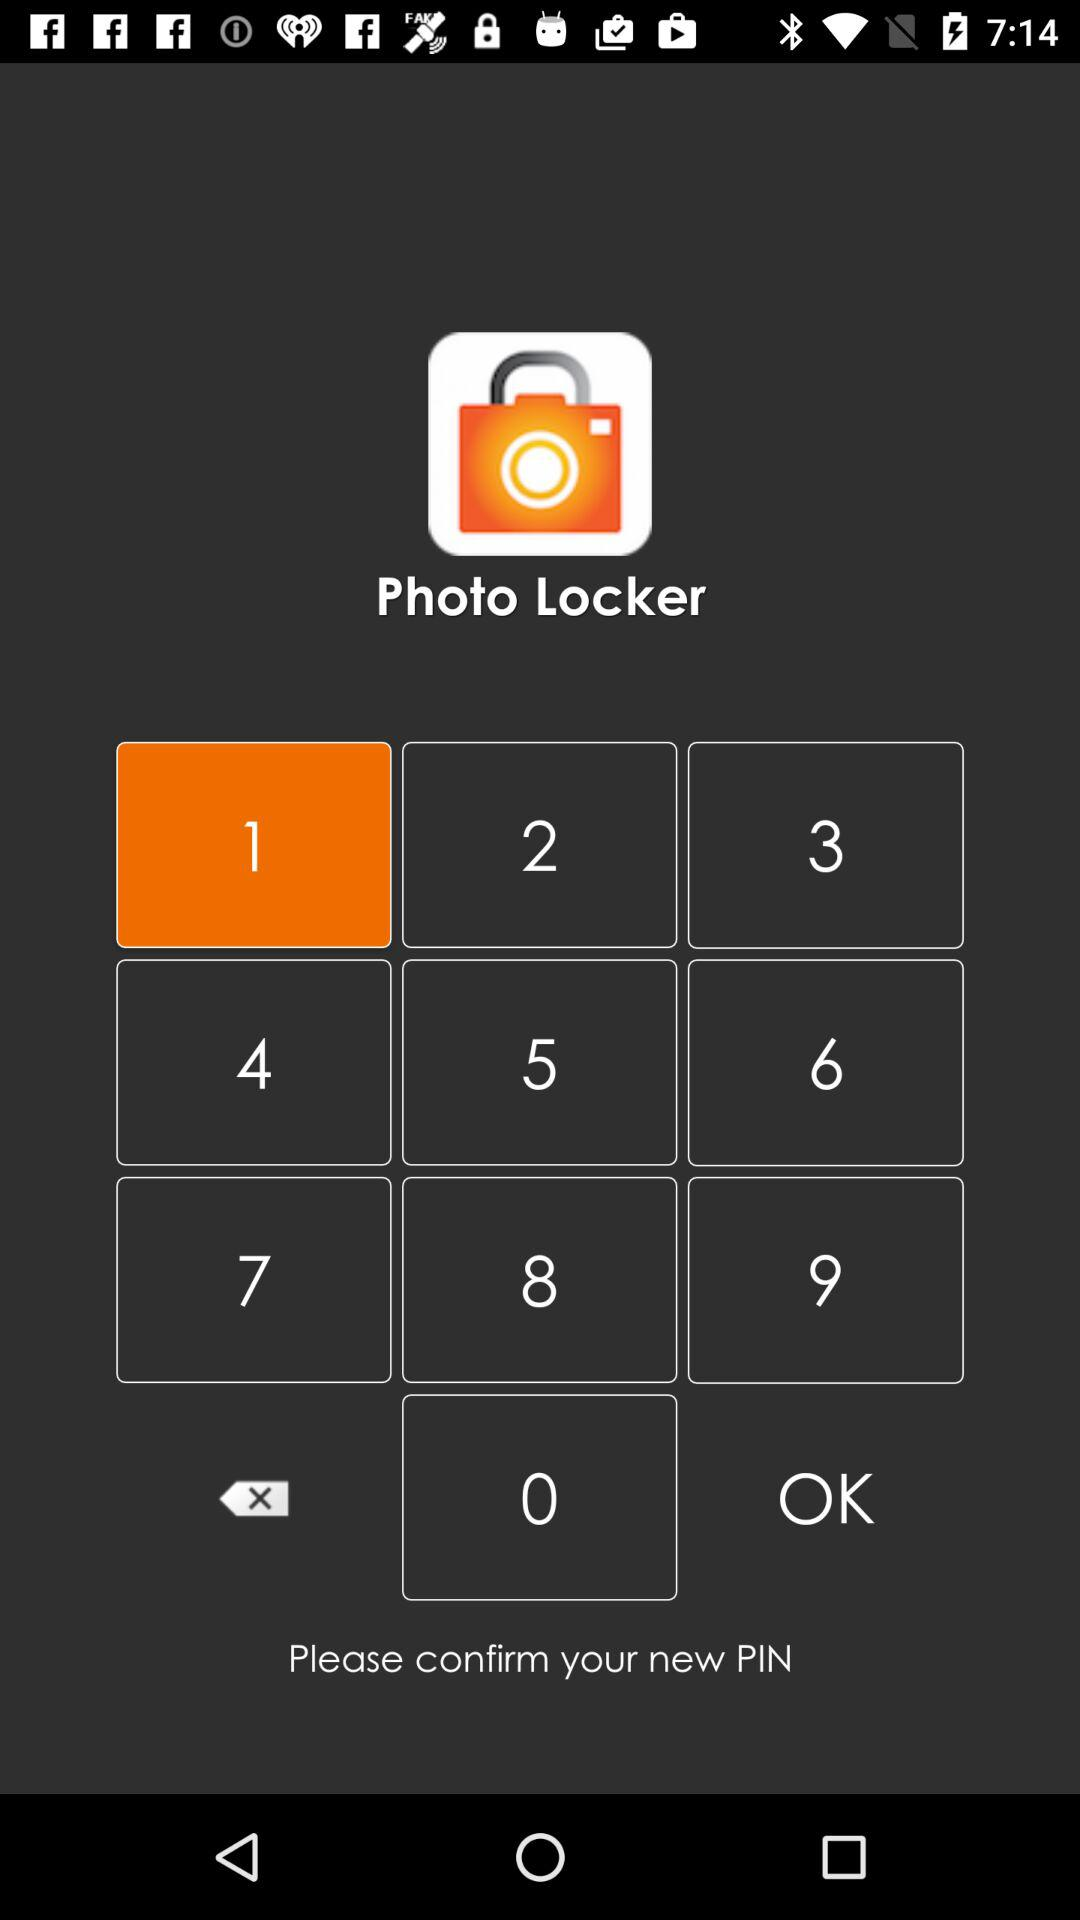How many digits are required for the PIN?
When the provided information is insufficient, respond with <no answer>. <no answer> 